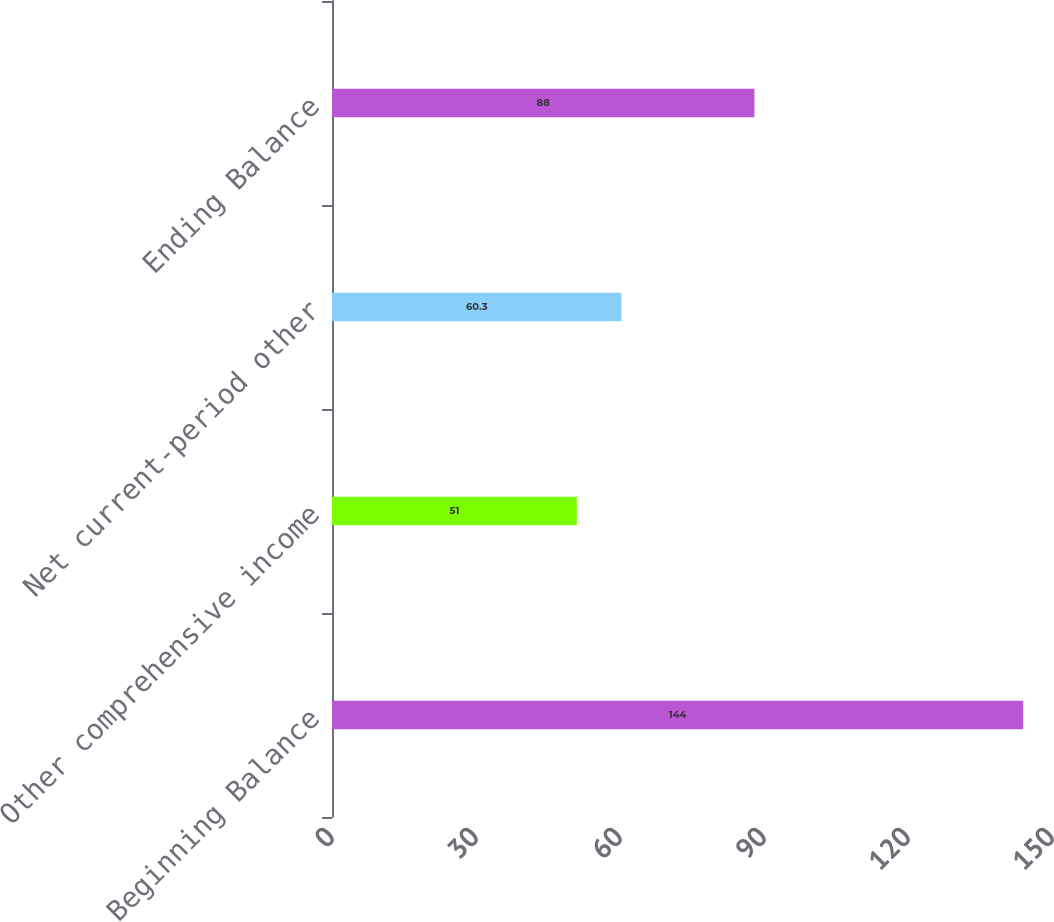<chart> <loc_0><loc_0><loc_500><loc_500><bar_chart><fcel>Beginning Balance<fcel>Other comprehensive income<fcel>Net current-period other<fcel>Ending Balance<nl><fcel>144<fcel>51<fcel>60.3<fcel>88<nl></chart> 